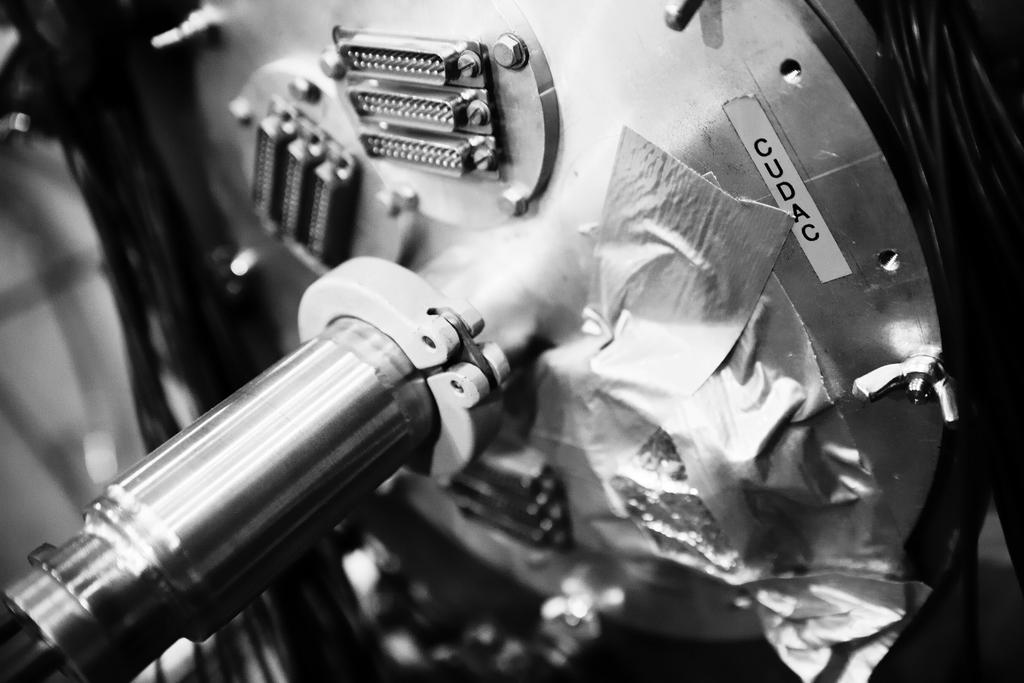What is the main subject in the image? There is a big machine in the image. What else can be seen in the image besides the machine? There are chairs in the image. What is attached to the machine in the image? There is text paper attached to the machine in the image. What type of crime is being committed in the image? There is no indication of a crime being committed in the image; it features a big machine with chairs and text paper attached. Can you see any birds in the image? There are no birds present in the image. 